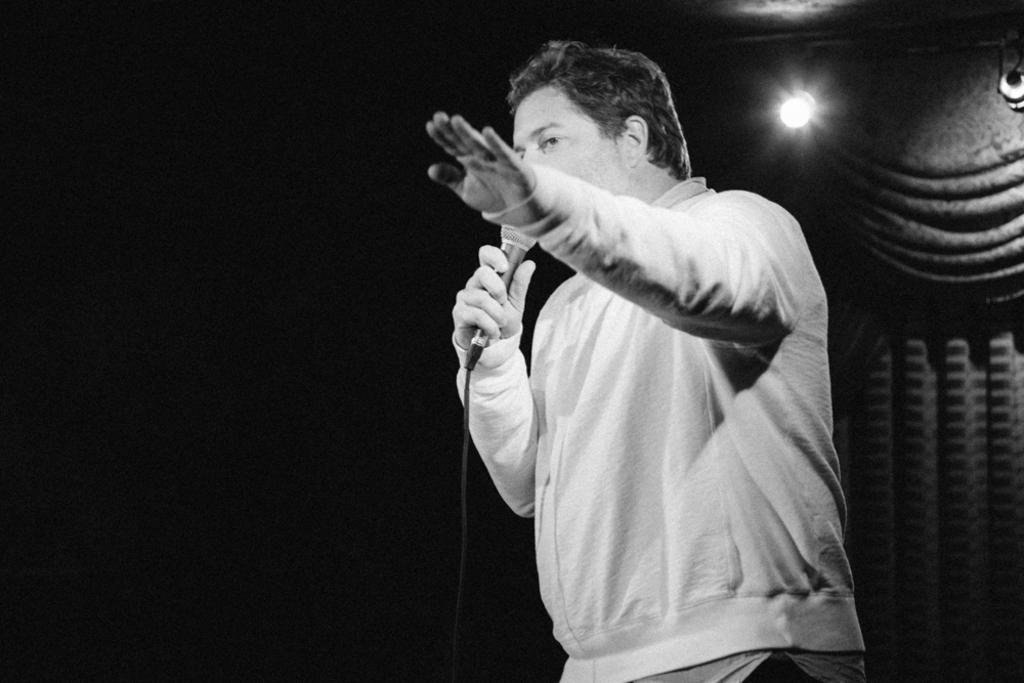What is the color scheme of the image? The image is black and white. What can be seen in the image? There is a man standing in the image. What is the man holding in the image? The man is holding a microphone. What is the man doing in the image? The man is talking. What is attached to the wall in the image? There is a bulb attached to the wall in the image. What type of window treatment is present in the image? There is a curtain hanging in the image. What type of brush is the man using to paint the card in the image? There is no brush or card present in the image. The man is holding a microphone and talking, and there is a bulb and a curtain in the image. 